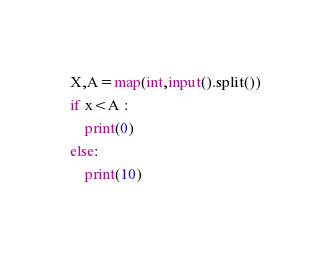<code> <loc_0><loc_0><loc_500><loc_500><_Python_>X,A=map(int,input().split())
if x<A :
    print(0)
else:
    print(10)
</code> 